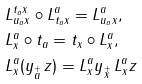Convert formula to latex. <formula><loc_0><loc_0><loc_500><loc_500>& L _ { u _ { a } x } ^ { t _ { a } x } \circ L _ { t _ { a } x } ^ { a } = L _ { u _ { a } x } ^ { a } , \\ & L _ { x } ^ { a } \circ { t _ { a } } = t _ { x } \circ L _ { x } ^ { a } , \\ & L _ { x } ^ { a } ( y _ { \stackrel { \mathbf + } { a } } \, z ) = L _ { x } ^ { a } y _ { \stackrel { \mathbf + } { x } } \, L _ { x } ^ { a } z</formula> 